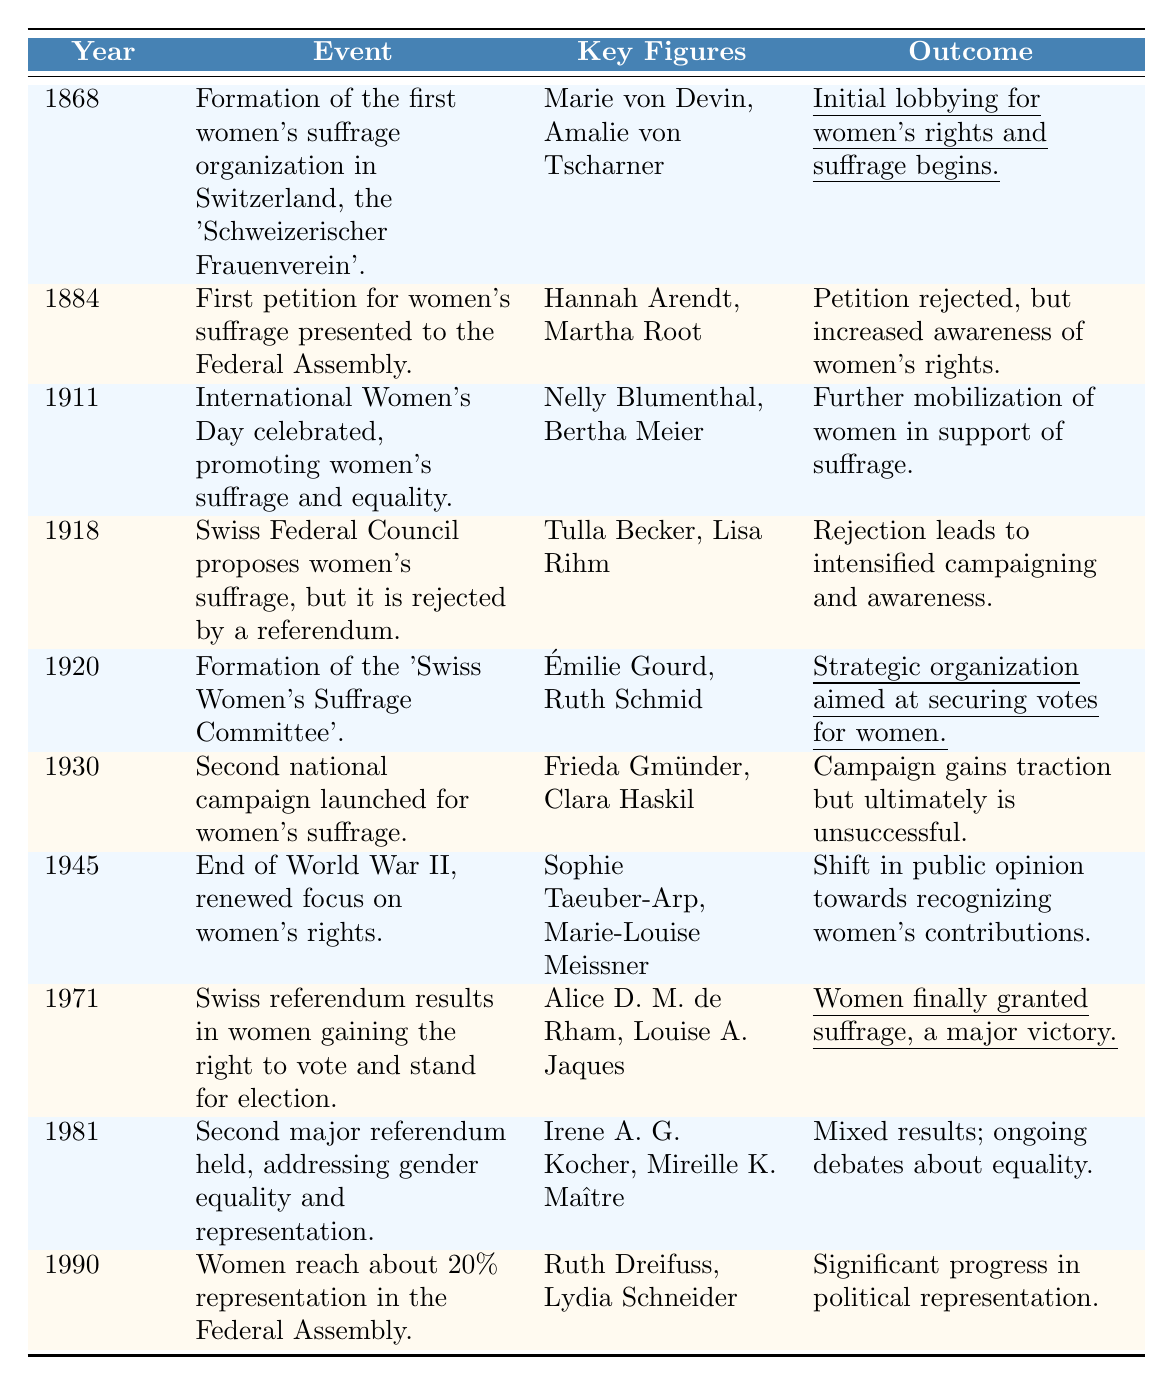What year was the first women's suffrage organization formed in Switzerland? The table indicates that the first women's suffrage organization, the 'Schweizerischer Frauenverein', was formed in 1868.
Answer: 1868 Who were the key figures involved in the formation of the first women's suffrage organization? The key figures listed in the table for this event are Marie von Devin and Amalie von Tscharner.
Answer: Marie von Devin and Amalie von Tscharner What was the outcome of the first petition for women's suffrage in 1884? According to the table, the petition was rejected, but it increased awareness of women's rights.
Answer: Petition rejected; increased awareness In which year did women in Switzerland finally gain the right to vote? The table states that women were granted suffrage in 1971 following a referendum.
Answer: 1971 How many key figures are mentioned for the event when International Women's Day was celebrated in 1911? The table shows that two key figures, Nelly Blumenthal and Bertha Meier, are mentioned for this event.
Answer: Two What was the major outcome of the second national campaign for women's suffrage in 1930? The table notes that while the campaign gained traction, it ultimately was unsuccessful.
Answer: Unsuccessful campaign Was there a significant event related to women's suffrage in 1945? Yes, the table indicates that there was a renewed focus on women's rights following the end of World War II.
Answer: Yes What was the outcome of the Swiss referendum in 1981 regarding gender equality? The outcome was mixed results, leading to ongoing debates about equality, as per the table.
Answer: Mixed results; ongoing debates How many years passed between the formation of the 'Swiss Women’s Suffrage Committee' in 1920 and women gaining the right to vote in 1971? The difference can be calculated as 1971 - 1920 = 51 years.
Answer: 51 years Which two key figures were significant in the year when women reached approximately 20% representation in the Federal Assembly? The table identifies Ruth Dreifuss and Lydia Schneider as the key figures for the year 1990.
Answer: Ruth Dreifuss and Lydia Schneider In what way did public opinion shift after the end of WWII according to the table? The table states that there was a shift in public opinion towards recognizing women's contributions after WWII.
Answer: Recognition of women’s contributions What does the repeated mention of key figures across different events tell us about women's suffrage advocacy in Switzerland? It indicates that the same individuals remained engaged and influential in the women's suffrage movement over time, suggesting a dedicated effort towards advocacy.
Answer: Continued engagement of advocates How did the outcome of the women's suffrage proposals change from 1918 to 1971? In 1918, the proposal was rejected by a referendum, while in 1971, women were granted the right to vote, indicating a significant change in societal acceptance over this period.
Answer: Significant positive change Which event in 1945 marked a renewed focus on women's rights? The end of World War II marked this renewed focus, as indicated in the table.
Answer: End of World War II How many times is the word "suffrage" mentioned in the events listed for the years 1868 to 1990? The word "suffrage" appears in the events listed for 1868, 1911, 1918, 1920, 1930, 1971, and multiple times. Counting all occurrences gives a total of 8.
Answer: 8 times 